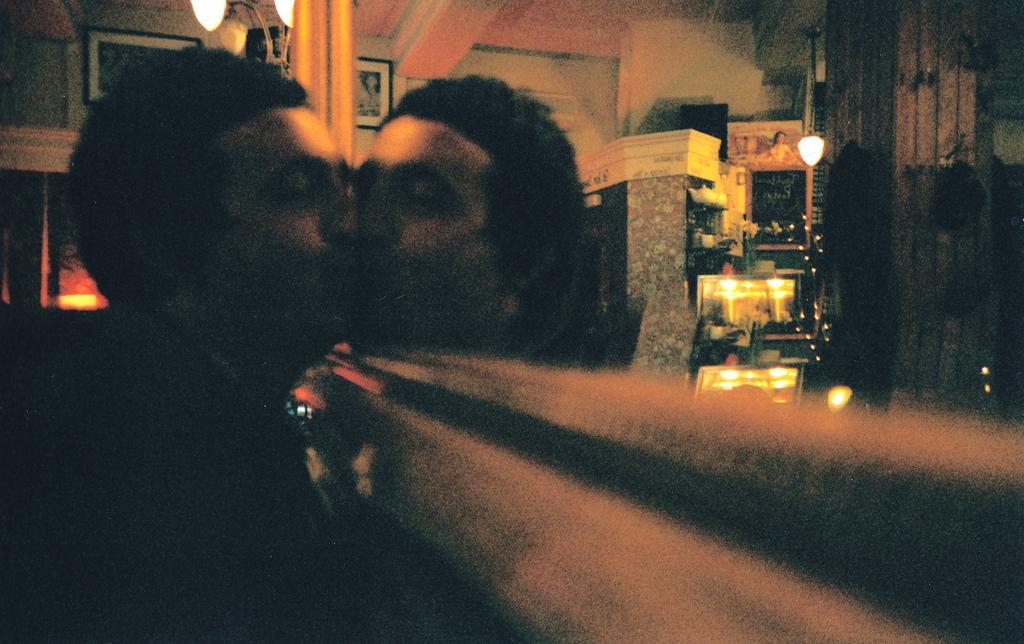How would you summarize this image in a sentence or two? This picture is blurry and dark, there is a person, in front of this person we can see mirror, in this mirror we can see reflection of person and we can see boards, lights, flowers and wall. In the background we can see lights and frame. 